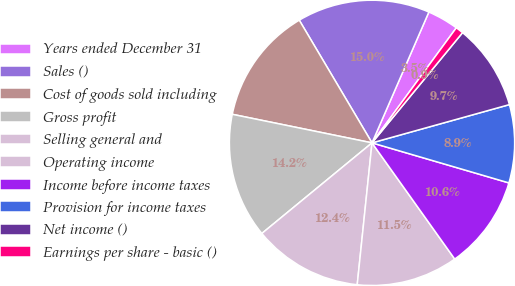Convert chart to OTSL. <chart><loc_0><loc_0><loc_500><loc_500><pie_chart><fcel>Years ended December 31<fcel>Sales ()<fcel>Cost of goods sold including<fcel>Gross profit<fcel>Selling general and<fcel>Operating income<fcel>Income before income taxes<fcel>Provision for income taxes<fcel>Net income ()<fcel>Earnings per share - basic ()<nl><fcel>3.54%<fcel>15.04%<fcel>13.27%<fcel>14.16%<fcel>12.39%<fcel>11.5%<fcel>10.62%<fcel>8.85%<fcel>9.73%<fcel>0.88%<nl></chart> 